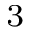Convert formula to latex. <formula><loc_0><loc_0><loc_500><loc_500>^ { 3 }</formula> 